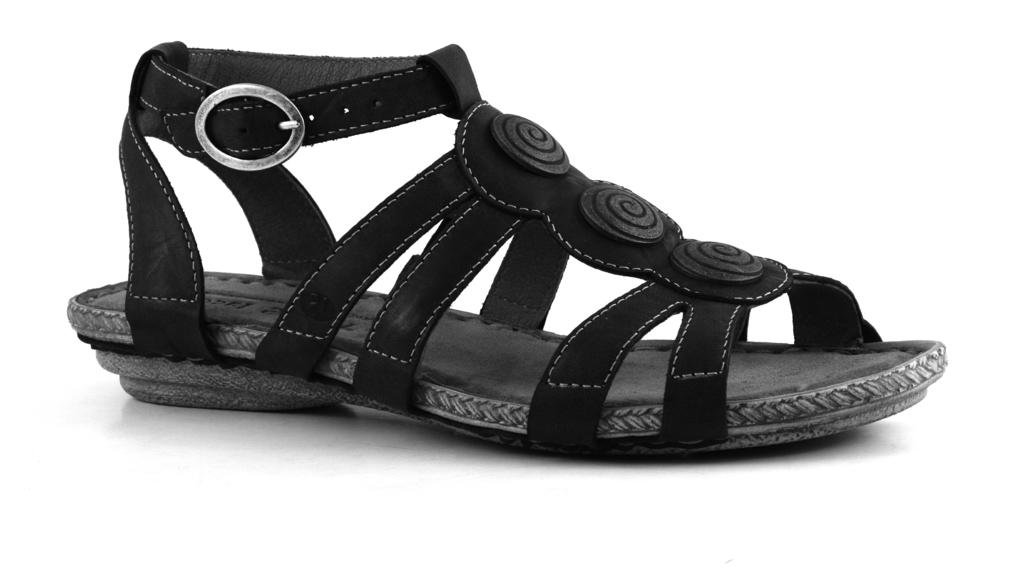What type of footwear is visible in the foreground of the image? There are sandals in the foreground of the image. Can you describe the location of the sandals? The sandals may be on the floor. What type of setting is depicted in the image? The image appears to be taken in a hall. What type of feather can be seen on the sandals in the image? There is no feather present on the sandals in the image. What purpose does the stamp serve in the image? There is no stamp present in the image. 